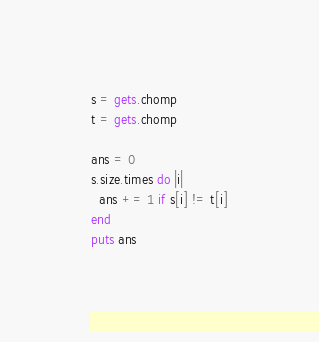Convert code to text. <code><loc_0><loc_0><loc_500><loc_500><_Ruby_>s = gets.chomp
t = gets.chomp

ans = 0
s.size.times do |i|
  ans += 1 if s[i] != t[i]
end
puts ans
</code> 